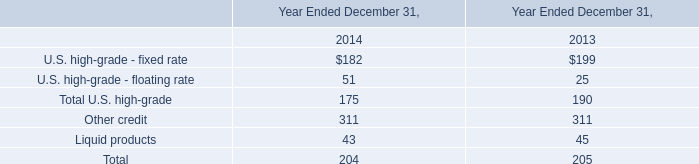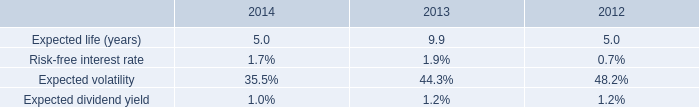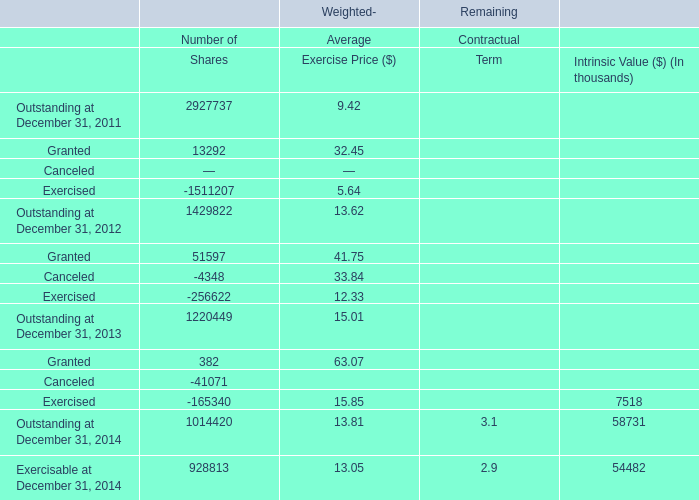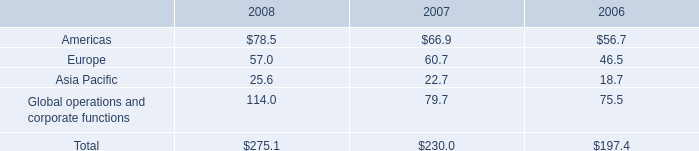what was the percentage change in total rent expense from 2007 to 2008? 
Computations: ((41.4 - 37.1) / 37.1)
Answer: 0.1159. 